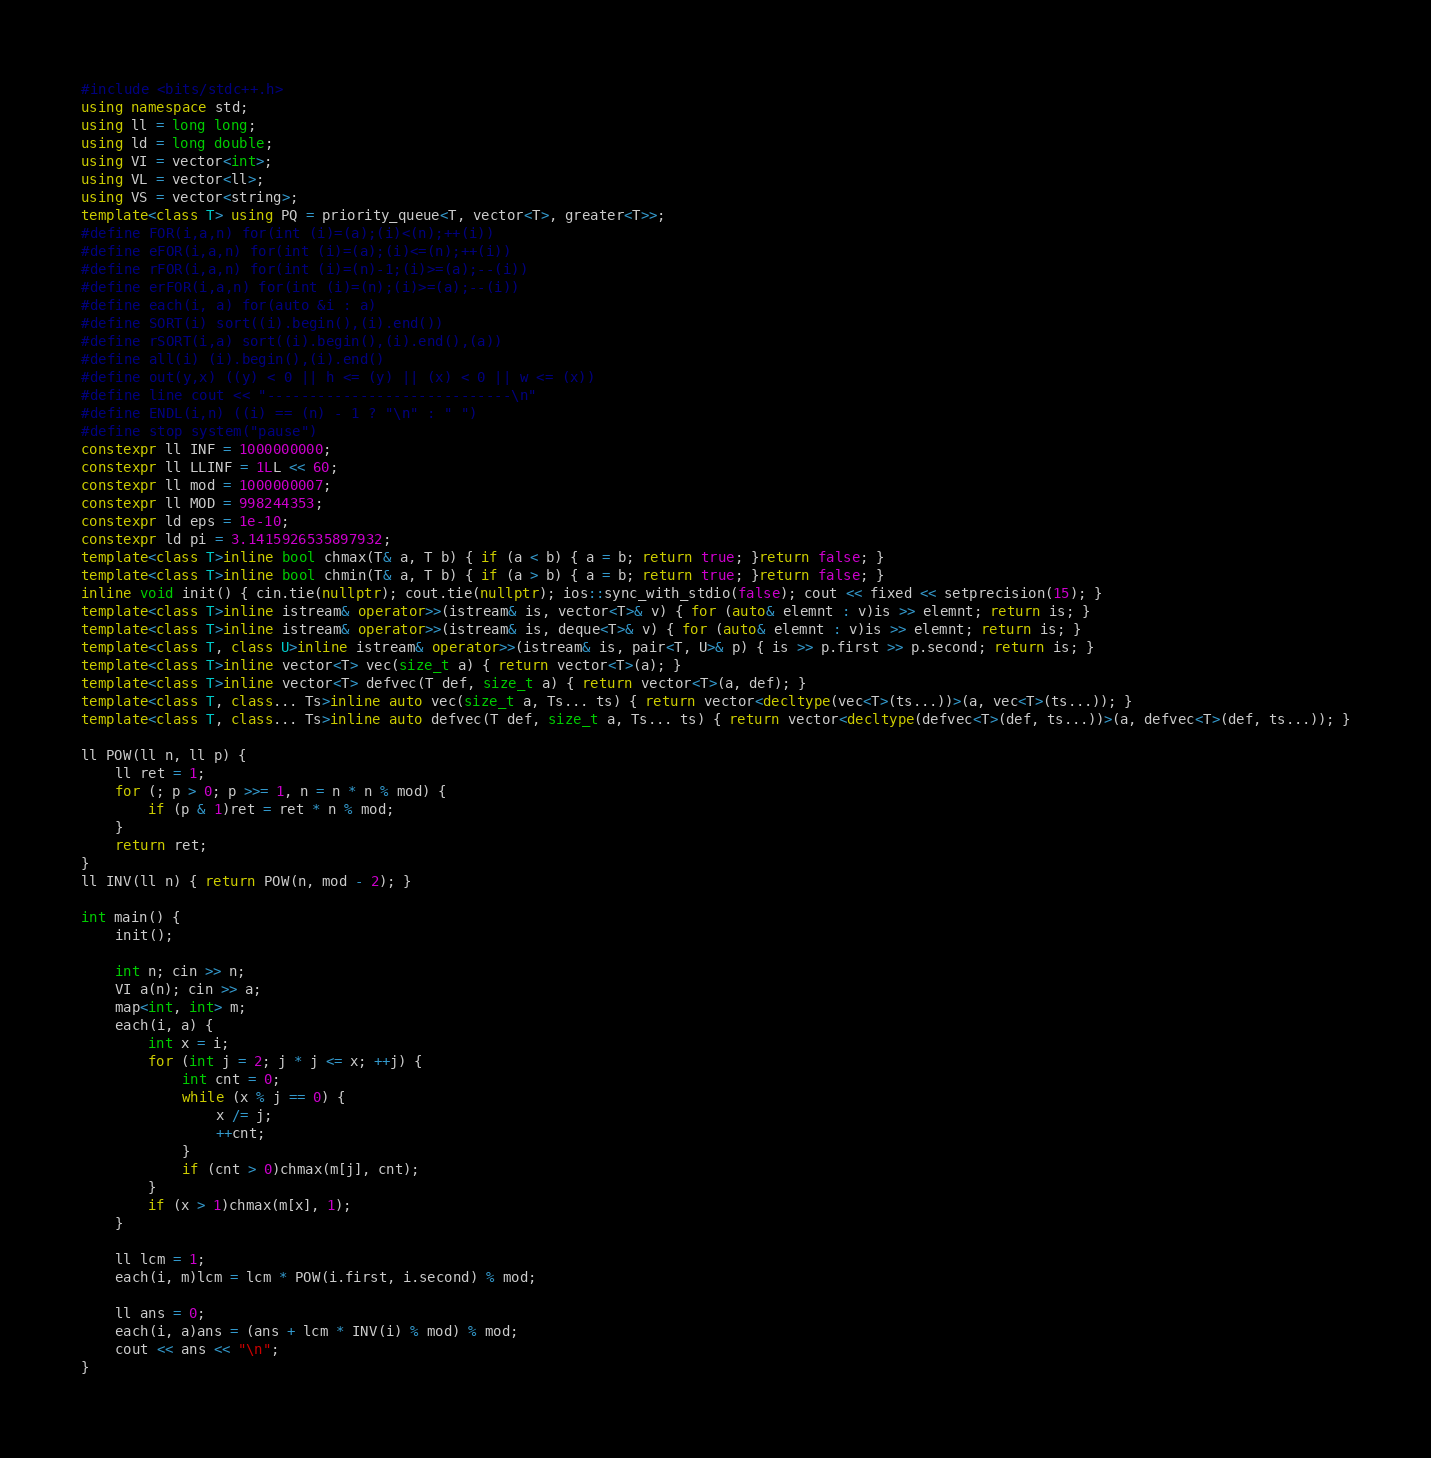<code> <loc_0><loc_0><loc_500><loc_500><_C++_>#include <bits/stdc++.h>
using namespace std;
using ll = long long;
using ld = long double;
using VI = vector<int>;
using VL = vector<ll>;
using VS = vector<string>;
template<class T> using PQ = priority_queue<T, vector<T>, greater<T>>;
#define FOR(i,a,n) for(int (i)=(a);(i)<(n);++(i))
#define eFOR(i,a,n) for(int (i)=(a);(i)<=(n);++(i))
#define rFOR(i,a,n) for(int (i)=(n)-1;(i)>=(a);--(i))
#define erFOR(i,a,n) for(int (i)=(n);(i)>=(a);--(i))
#define each(i, a) for(auto &i : a)
#define SORT(i) sort((i).begin(),(i).end())
#define rSORT(i,a) sort((i).begin(),(i).end(),(a))
#define all(i) (i).begin(),(i).end()
#define out(y,x) ((y) < 0 || h <= (y) || (x) < 0 || w <= (x))
#define line cout << "-----------------------------\n" 
#define ENDL(i,n) ((i) == (n) - 1 ? "\n" : " ")
#define stop system("pause")
constexpr ll INF = 1000000000;
constexpr ll LLINF = 1LL << 60;
constexpr ll mod = 1000000007;
constexpr ll MOD = 998244353;
constexpr ld eps = 1e-10;
constexpr ld pi = 3.1415926535897932;
template<class T>inline bool chmax(T& a, T b) { if (a < b) { a = b; return true; }return false; }
template<class T>inline bool chmin(T& a, T b) { if (a > b) { a = b; return true; }return false; }
inline void init() { cin.tie(nullptr); cout.tie(nullptr); ios::sync_with_stdio(false); cout << fixed << setprecision(15); }
template<class T>inline istream& operator>>(istream& is, vector<T>& v) { for (auto& elemnt : v)is >> elemnt; return is; }
template<class T>inline istream& operator>>(istream& is, deque<T>& v) { for (auto& elemnt : v)is >> elemnt; return is; }
template<class T, class U>inline istream& operator>>(istream& is, pair<T, U>& p) { is >> p.first >> p.second; return is; }
template<class T>inline vector<T> vec(size_t a) { return vector<T>(a); }
template<class T>inline vector<T> defvec(T def, size_t a) { return vector<T>(a, def); }
template<class T, class... Ts>inline auto vec(size_t a, Ts... ts) { return vector<decltype(vec<T>(ts...))>(a, vec<T>(ts...)); }
template<class T, class... Ts>inline auto defvec(T def, size_t a, Ts... ts) { return vector<decltype(defvec<T>(def, ts...))>(a, defvec<T>(def, ts...)); }

ll POW(ll n, ll p) {
    ll ret = 1;
    for (; p > 0; p >>= 1, n = n * n % mod) {
        if (p & 1)ret = ret * n % mod;
    }
    return ret;
}
ll INV(ll n) { return POW(n, mod - 2); }

int main() {
    init();

    int n; cin >> n;
    VI a(n); cin >> a;
    map<int, int> m;
    each(i, a) {
        int x = i;
        for (int j = 2; j * j <= x; ++j) {
            int cnt = 0;
            while (x % j == 0) {
                x /= j;
                ++cnt;
            }
            if (cnt > 0)chmax(m[j], cnt);
        }
        if (x > 1)chmax(m[x], 1);
    }

    ll lcm = 1;
    each(i, m)lcm = lcm * POW(i.first, i.second) % mod;

    ll ans = 0;
    each(i, a)ans = (ans + lcm * INV(i) % mod) % mod;
    cout << ans << "\n";
}</code> 